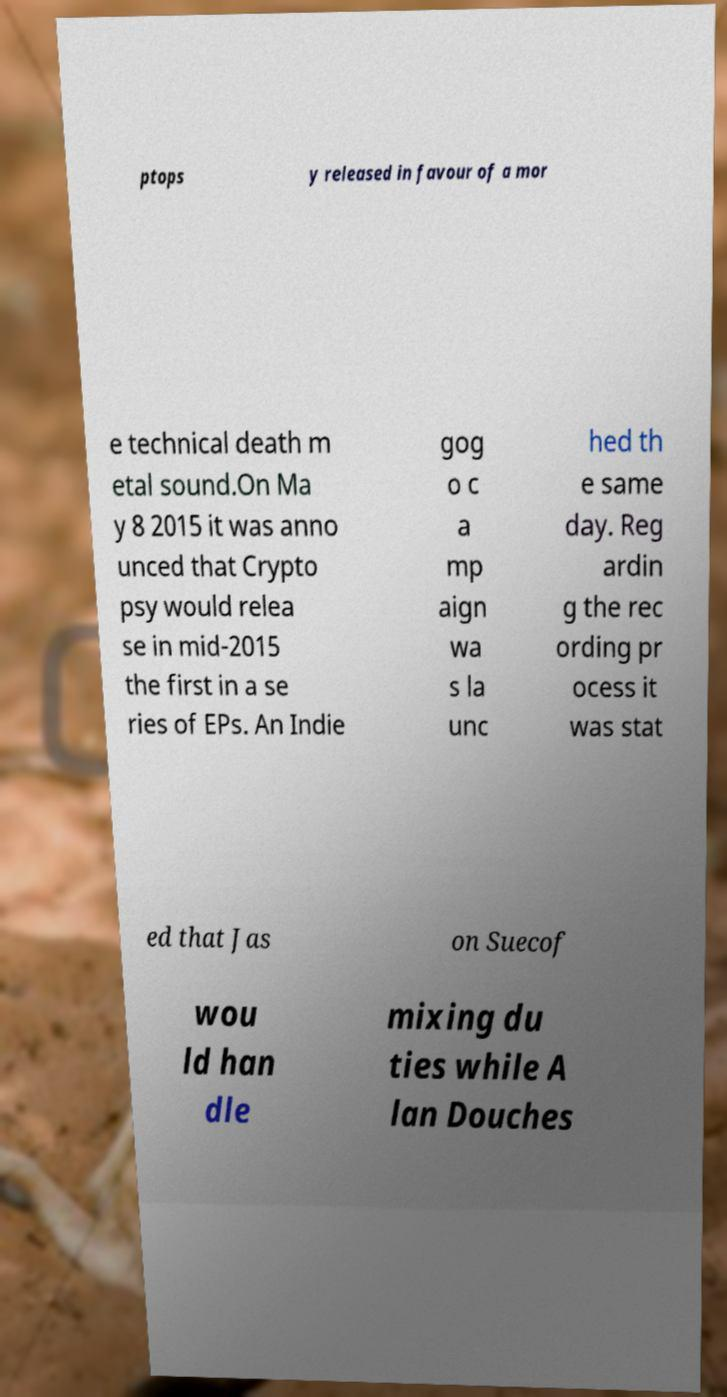Please identify and transcribe the text found in this image. ptops y released in favour of a mor e technical death m etal sound.On Ma y 8 2015 it was anno unced that Crypto psy would relea se in mid-2015 the first in a se ries of EPs. An Indie gog o c a mp aign wa s la unc hed th e same day. Reg ardin g the rec ording pr ocess it was stat ed that Jas on Suecof wou ld han dle mixing du ties while A lan Douches 